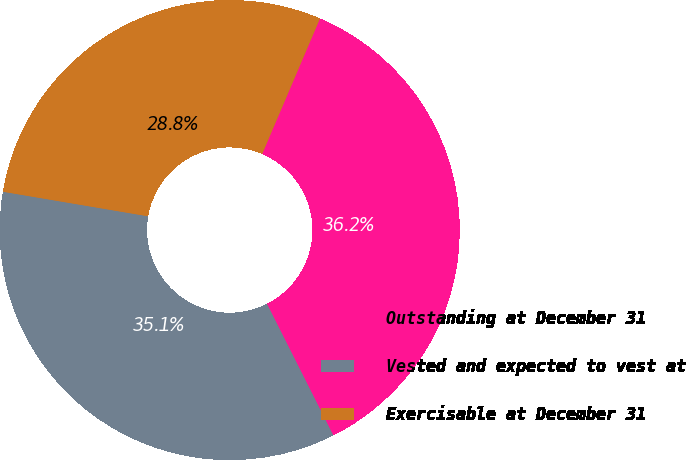Convert chart to OTSL. <chart><loc_0><loc_0><loc_500><loc_500><pie_chart><fcel>Outstanding at December 31<fcel>Vested and expected to vest at<fcel>Exercisable at December 31<nl><fcel>36.15%<fcel>35.1%<fcel>28.75%<nl></chart> 